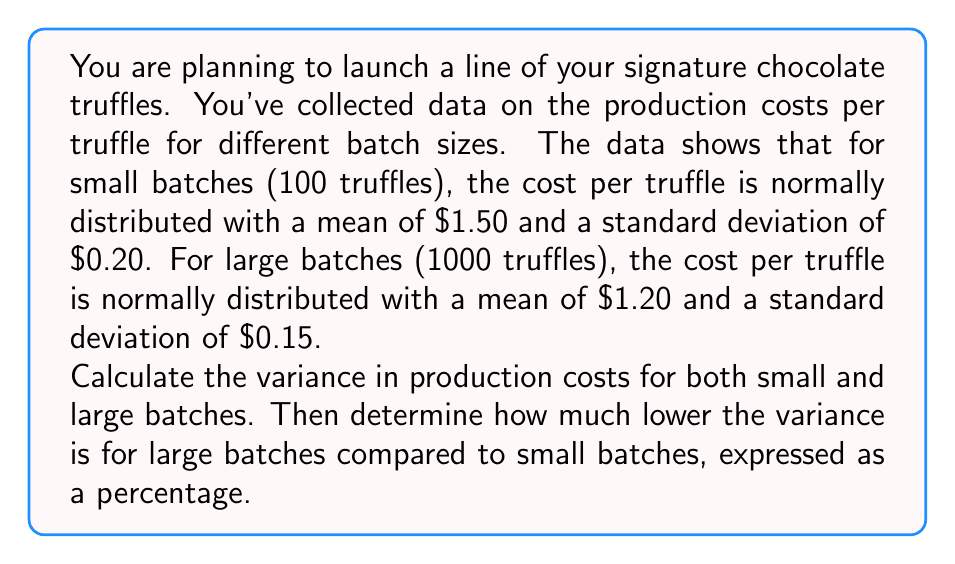What is the answer to this math problem? To solve this problem, we'll follow these steps:

1. Calculate the variance for small batches
2. Calculate the variance for large batches
3. Compare the variances and express the difference as a percentage

Step 1: Variance for small batches

The variance is the square of the standard deviation. For small batches, the standard deviation is $0.20.

$$\text{Variance}_{\text{small}} = (\text{Standard Deviation}_{\text{small}})^2 = (0.20)^2 = 0.04$$

Step 2: Variance for large batches

For large batches, the standard deviation is $0.15.

$$\text{Variance}_{\text{large}} = (\text{Standard Deviation}_{\text{large}})^2 = (0.15)^2 = 0.0225$$

Step 3: Compare variances and express difference as a percentage

To find how much lower the variance is for large batches, we calculate the difference and divide by the small batch variance:

$$\text{Difference} = \text{Variance}_{\text{small}} - \text{Variance}_{\text{large}} = 0.04 - 0.0225 = 0.0175$$

$$\text{Percentage difference} = \frac{\text{Difference}}{\text{Variance}_{\text{small}}} \times 100\% = \frac{0.0175}{0.04} \times 100\% = 43.75\%$$

Therefore, the variance for large batches is 43.75% lower than for small batches.
Answer: The variance in production costs for small batches is $0.04, and for large batches is $0.0225. The variance for large batches is 43.75% lower than for small batches. 